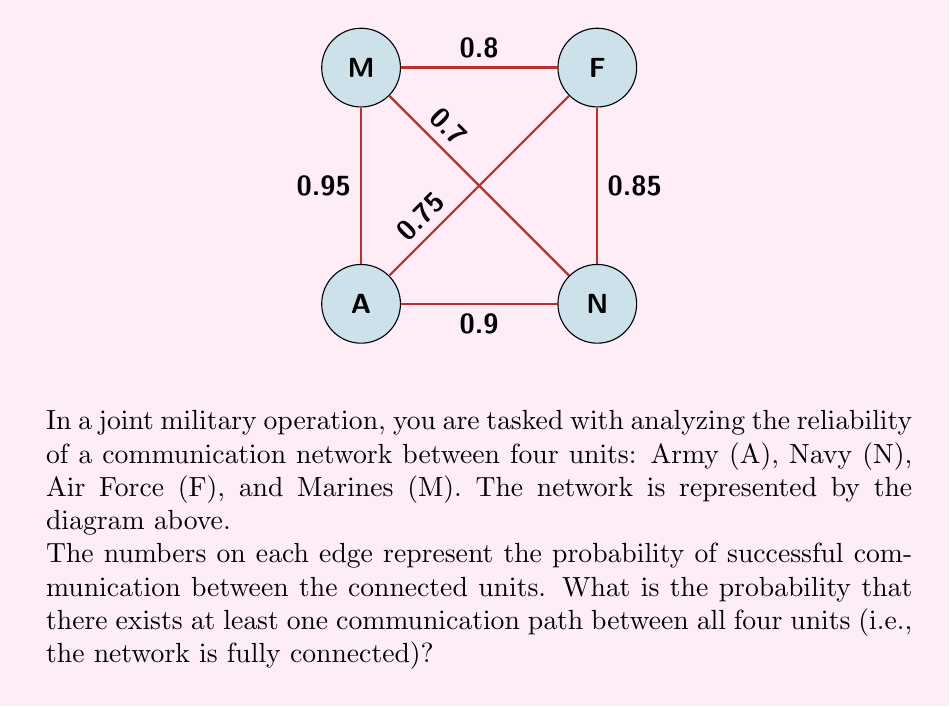Can you answer this question? To solve this problem, we'll use the concept of network reliability and probability theory. We'll follow these steps:

1) First, we need to find the probability that the network is not fully connected. This occurs when at least one unit is isolated from the others.

2) There are four ways a unit can be isolated:
   - A is isolated: $(1-0.9)(1-0.95)(1-0.75) = 0.001875$
   - N is isolated: $(1-0.9)(1-0.85)(1-0.7) = 0.021$
   - F is isolated: $(1-0.85)(1-0.8)(1-0.75) = 0.03$
   - M is isolated: $(1-0.95)(1-0.8)(1-0.7) = 0.0084$

3) However, we can't simply add these probabilities because there could be overlaps (e.g., both A and N could be isolated simultaneously).

4) To account for this, we'll use the Inclusion-Exclusion Principle. Let's define events:
   $A$: Unit A is isolated
   $N$: Unit N is isolated
   $F$: Unit F is isolated
   $M$: Unit M is isolated

5) The probability of at least one unit being isolated is:

   $$P(A \cup N \cup F \cup M) = P(A) + P(N) + P(F) + P(M)$$
   $$- P(A \cap N) - P(A \cap F) - P(A \cap M) - P(N \cap F) - P(N \cap M) - P(F \cap M)$$
   $$+ P(A \cap N \cap F) + P(A \cap N \cap M) + P(A \cap F \cap M) + P(N \cap F \cap M)$$
   $$- P(A \cap N \cap F \cap M)$$

6) Calculating each term:
   $P(A) = 0.001875$, $P(N) = 0.021$, $P(F) = 0.03$, $P(M) = 0.0084$
   $P(A \cap N) = (1-0.9)(1-0.75)(1-0.7) = 0.0225$
   $P(A \cap F) = (1-0.75)(1-0.95)(1-0.85) = 0.001875$
   $P(A \cap M) = (1-0.95)(1-0.75)(1-0.8) = 0.001$
   $P(N \cap F) = (1-0.85)(1-0.9)(1-0.7) = 0.0021$
   $P(N \cap M) = (1-0.7)(1-0.9)(1-0.85) = 0.00405$
   $P(F \cap M) = (1-0.8)(1-0.85)(1-0.75) = 0.00375$
   $P(A \cap N \cap F) = P(A \cap N \cap M) = P(A \cap F \cap M) = P(N \cap F \cap M) = 0$
   $P(A \cap N \cap F \cap M) = 0$

7) Substituting these values:

   $$P(\text{at least one unit isolated}) = 0.001875 + 0.021 + 0.03 + 0.0084$$
   $$- 0.0225 - 0.001875 - 0.001 - 0.0021 - 0.00405 - 0.00375 + 0 + 0 + 0 + 0 - 0$$
   $$= 0.0297$$

8) Therefore, the probability that the network is fully connected is:

   $$P(\text{fully connected}) = 1 - P(\text{at least one unit isolated}) = 1 - 0.0297 = 0.9703$$
Answer: 0.9703 